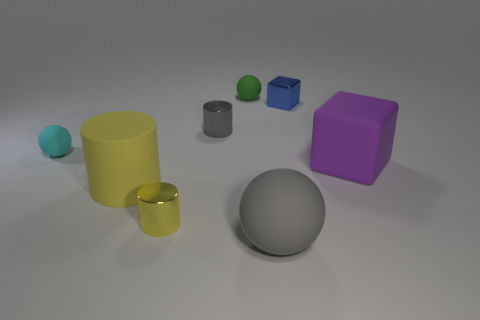Is the number of matte things to the right of the cyan rubber ball greater than the number of large purple matte things?
Your response must be concise. Yes. There is a matte thing that is to the right of the big gray rubber thing; how many big spheres are in front of it?
Ensure brevity in your answer.  1. There is a tiny rubber object that is on the right side of the big thing that is to the left of the rubber sphere that is to the right of the small green rubber object; what shape is it?
Your response must be concise. Sphere. What is the size of the gray ball?
Provide a short and direct response. Large. Is there a small blue cube made of the same material as the tiny green ball?
Offer a very short reply. No. There is a gray object that is the same shape as the small cyan thing; what size is it?
Give a very brief answer. Large. Are there the same number of cyan rubber things that are to the left of the blue metal cube and small yellow blocks?
Provide a succinct answer. No. There is a small metallic thing on the right side of the green matte thing; is its shape the same as the purple rubber object?
Make the answer very short. Yes. What is the shape of the blue object?
Offer a very short reply. Cube. The ball that is in front of the large rubber object that is left of the thing behind the small cube is made of what material?
Offer a terse response. Rubber. 